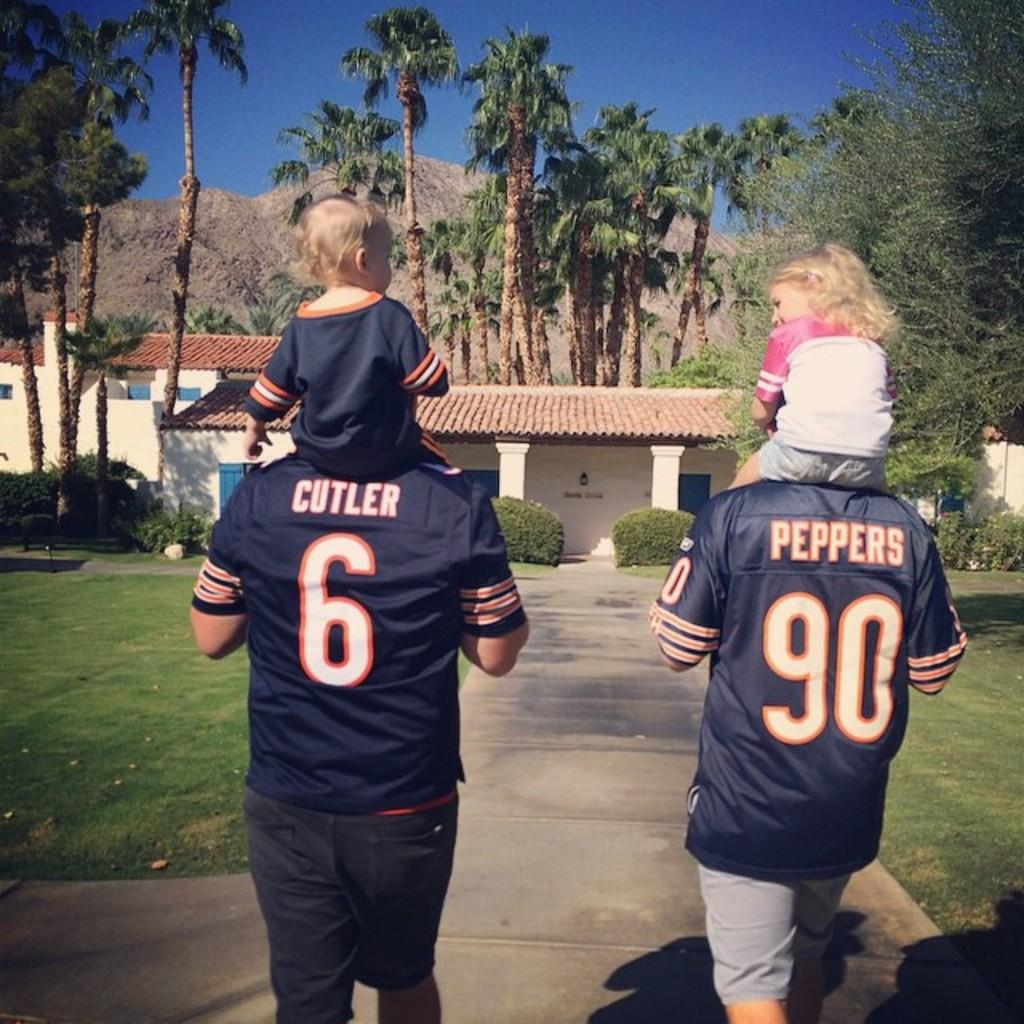<image>
Create a compact narrative representing the image presented. two people wearing jerseys reading Cutler and Peppers carry kids 